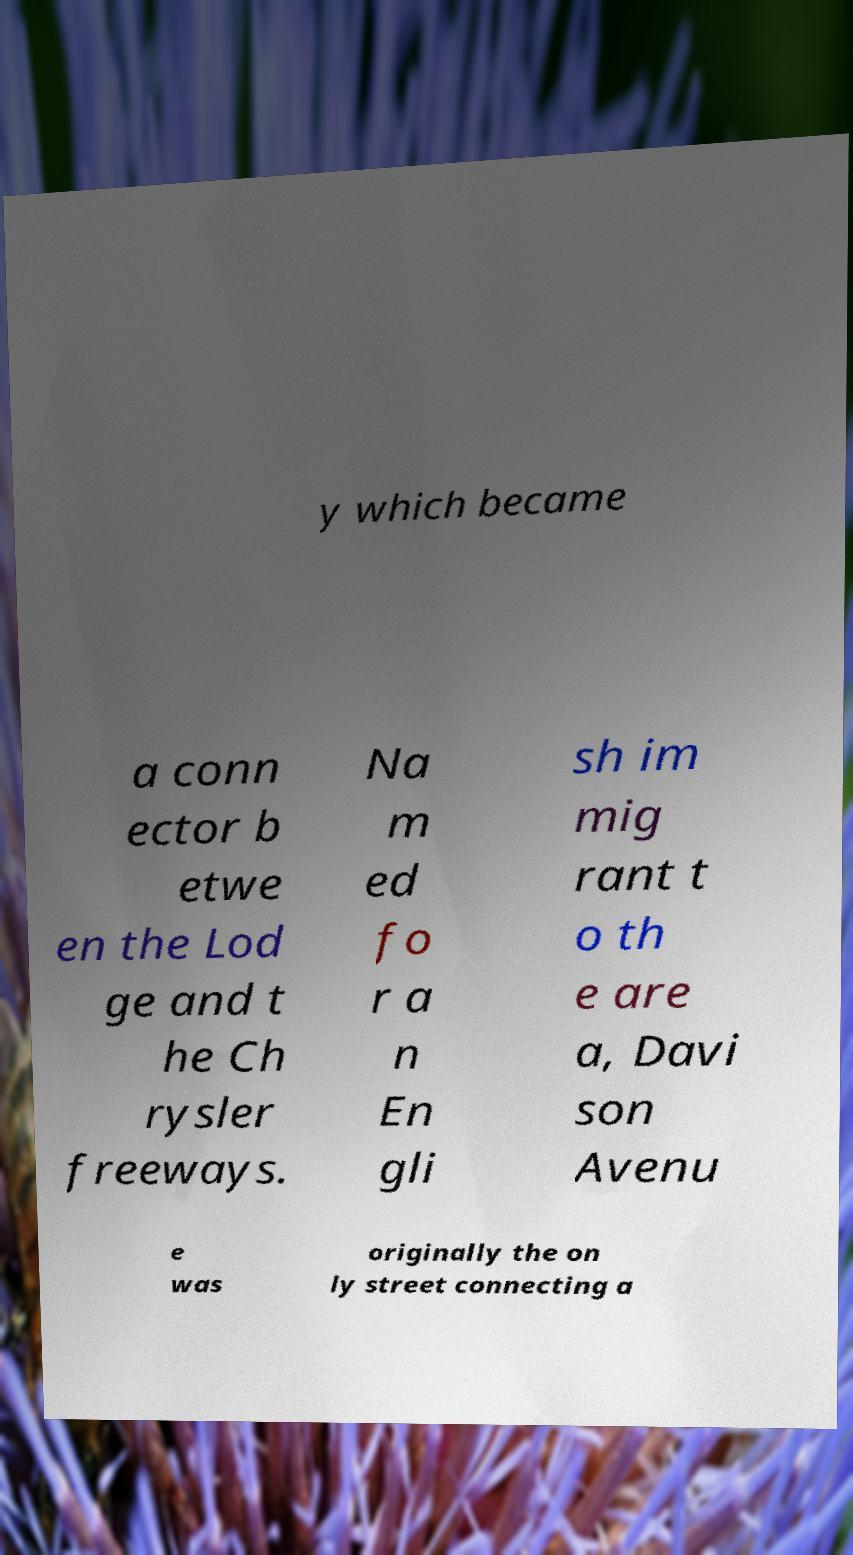I need the written content from this picture converted into text. Can you do that? y which became a conn ector b etwe en the Lod ge and t he Ch rysler freeways. Na m ed fo r a n En gli sh im mig rant t o th e are a, Davi son Avenu e was originally the on ly street connecting a 